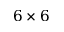Convert formula to latex. <formula><loc_0><loc_0><loc_500><loc_500>6 \times 6</formula> 